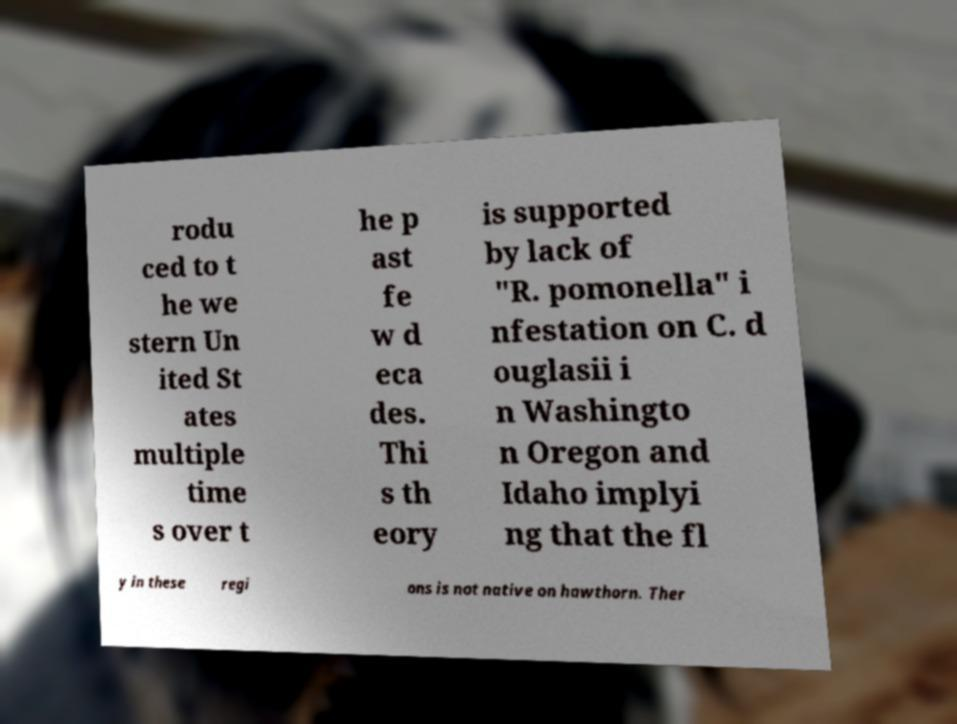Please read and relay the text visible in this image. What does it say? rodu ced to t he we stern Un ited St ates multiple time s over t he p ast fe w d eca des. Thi s th eory is supported by lack of "R. pomonella" i nfestation on C. d ouglasii i n Washingto n Oregon and Idaho implyi ng that the fl y in these regi ons is not native on hawthorn. Ther 